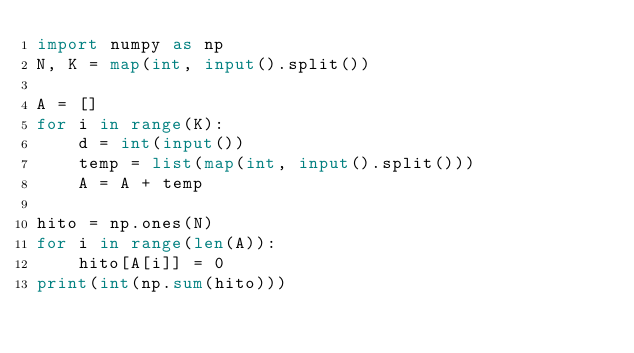Convert code to text. <code><loc_0><loc_0><loc_500><loc_500><_Python_>import numpy as np
N, K = map(int, input().split())

A = []
for i in range(K):
    d = int(input())
    temp = list(map(int, input().split()))
    A = A + temp

hito = np.ones(N)
for i in range(len(A)):
    hito[A[i]] = 0
print(int(np.sum(hito)))</code> 